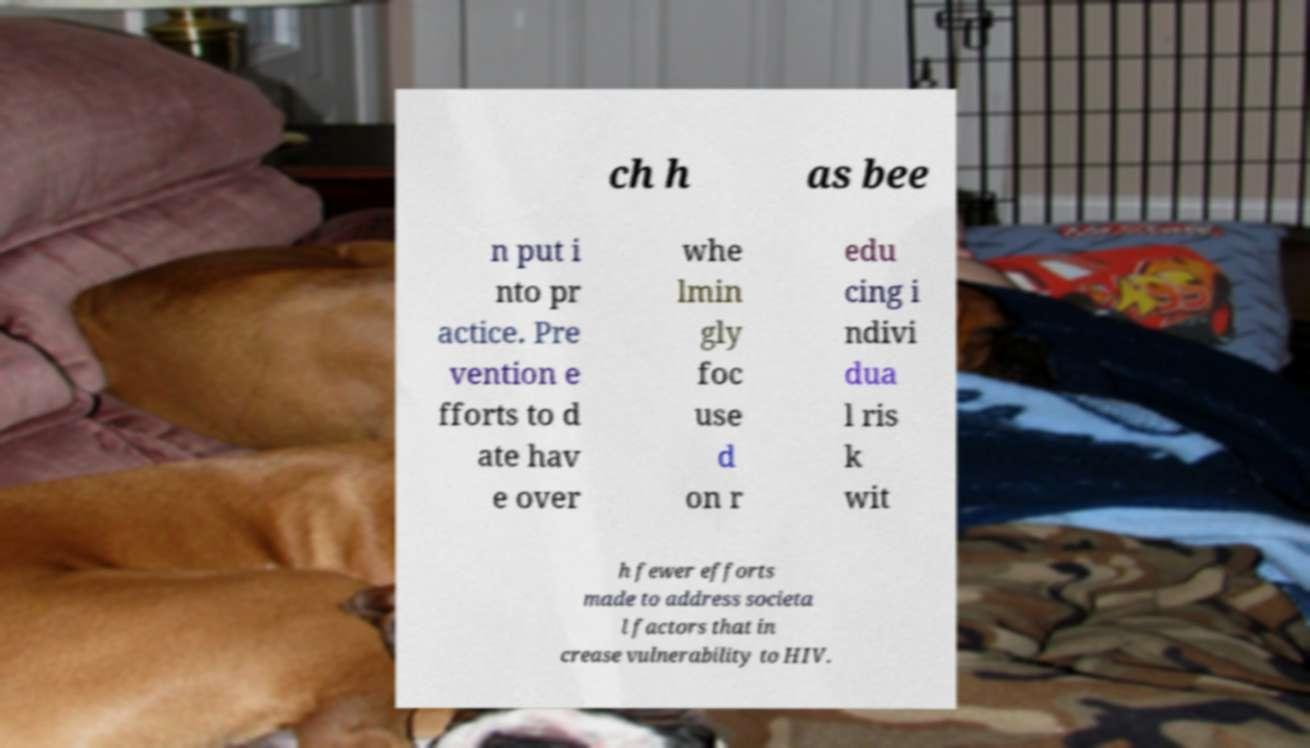Please identify and transcribe the text found in this image. ch h as bee n put i nto pr actice. Pre vention e fforts to d ate hav e over whe lmin gly foc use d on r edu cing i ndivi dua l ris k wit h fewer efforts made to address societa l factors that in crease vulnerability to HIV. 